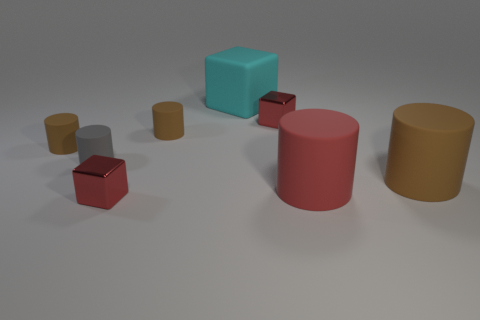How many brown cylinders must be subtracted to get 1 brown cylinders? 2 Subtract all cyan spheres. How many brown cylinders are left? 3 Subtract all gray cylinders. How many cylinders are left? 4 Subtract all small gray rubber cylinders. How many cylinders are left? 4 Subtract all yellow cylinders. Subtract all green balls. How many cylinders are left? 5 Add 2 small purple cubes. How many objects exist? 10 Subtract all cylinders. How many objects are left? 3 Add 7 small gray matte things. How many small gray matte things are left? 8 Add 5 tiny cylinders. How many tiny cylinders exist? 8 Subtract 0 blue spheres. How many objects are left? 8 